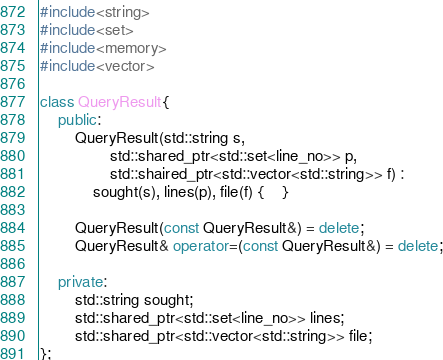<code> <loc_0><loc_0><loc_500><loc_500><_C++_>#include<string>
#include<set>
#include<memory>
#include<vector>

class QueryResult{
	public:
		QueryResult(std::string s,
				std::shared_ptr<std::set<line_no>> p,
				std::shaired_ptr<std::vector<std::string>> f) : 
			sought(s), lines(p), file(f) {	}

		QueryResult(const QueryResult&) = delete;
		QueryResult& operator=(const QueryResult&) = delete;
		
	private:
		std::string sought;
		std::shared_ptr<std::set<line_no>> lines;
		std::shared_ptr<std::vector<std::string>> file;
};
</code> 